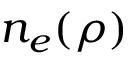Convert formula to latex. <formula><loc_0><loc_0><loc_500><loc_500>n _ { e } ( \rho )</formula> 